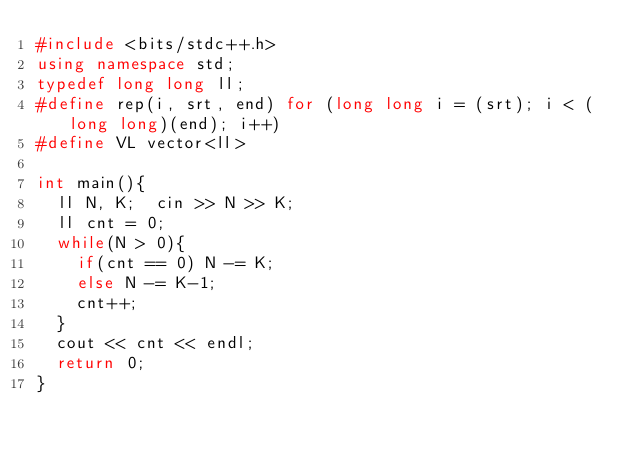Convert code to text. <code><loc_0><loc_0><loc_500><loc_500><_C++_>#include <bits/stdc++.h>
using namespace std;
typedef long long ll;
#define rep(i, srt, end) for (long long i = (srt); i < (long long)(end); i++)
#define VL vector<ll>

int main(){
  ll N, K;  cin >> N >> K;
  ll cnt = 0;
  while(N > 0){
    if(cnt == 0) N -= K;
    else N -= K-1;
    cnt++;
  }
  cout << cnt << endl;
  return 0;
}</code> 